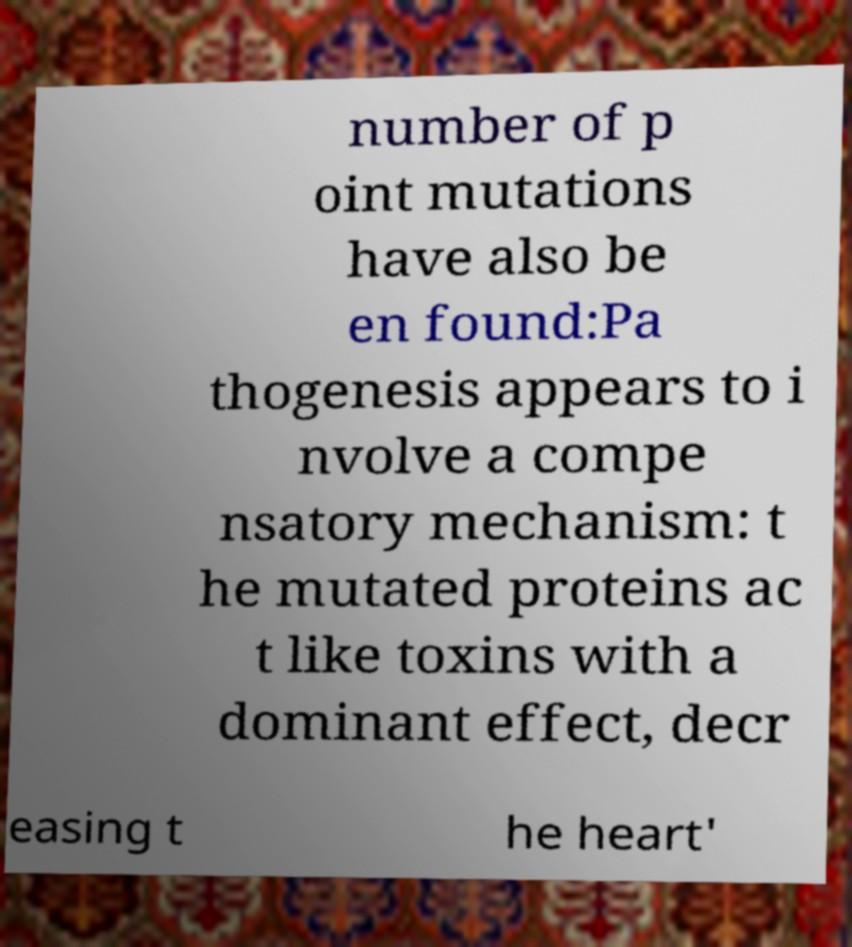Can you accurately transcribe the text from the provided image for me? number of p oint mutations have also be en found:Pa thogenesis appears to i nvolve a compe nsatory mechanism: t he mutated proteins ac t like toxins with a dominant effect, decr easing t he heart' 